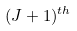<formula> <loc_0><loc_0><loc_500><loc_500>( J + 1 ) ^ { t h }</formula> 